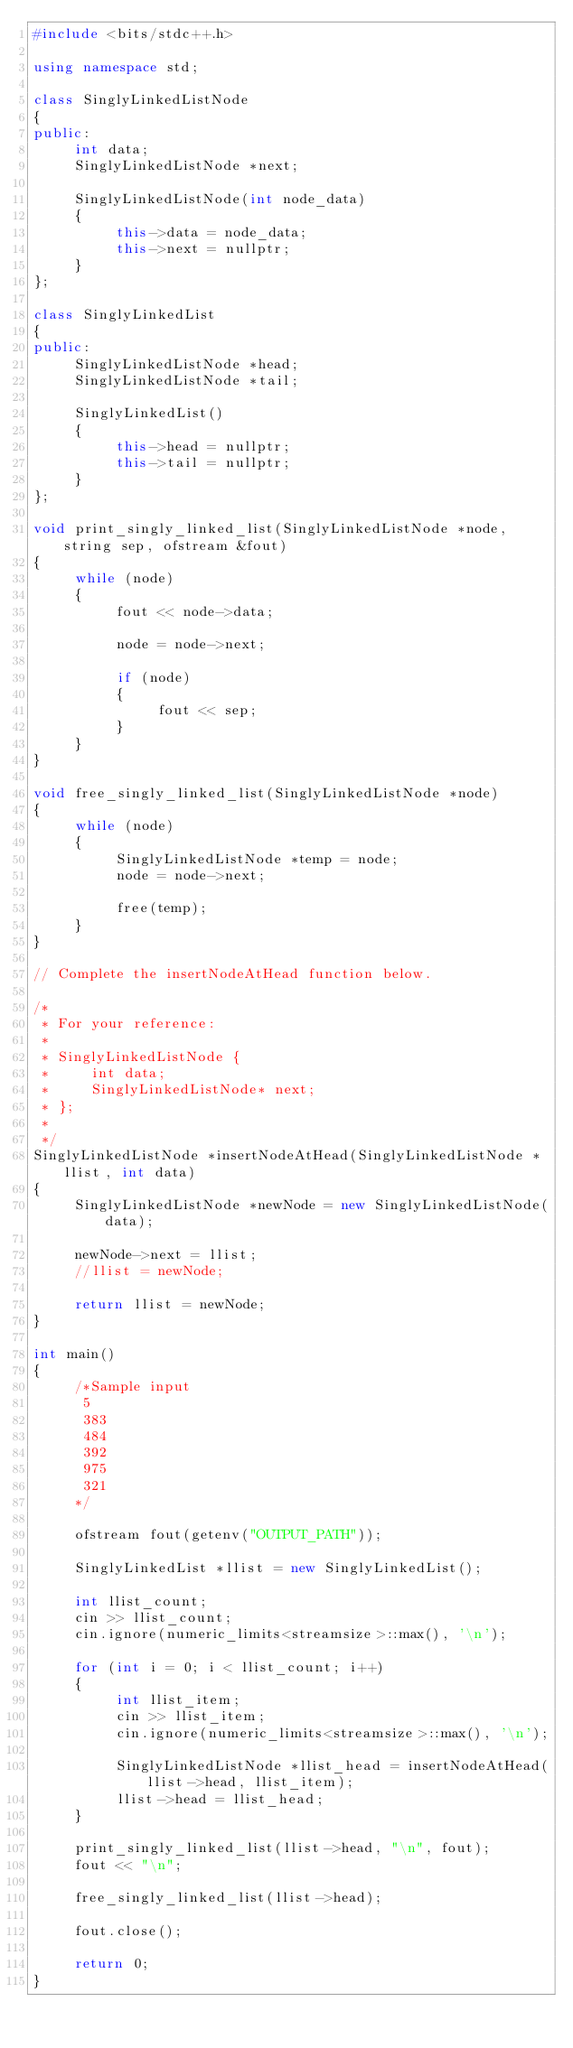Convert code to text. <code><loc_0><loc_0><loc_500><loc_500><_C++_>#include <bits/stdc++.h>

using namespace std;

class SinglyLinkedListNode
{
public:
     int data;
     SinglyLinkedListNode *next;

     SinglyLinkedListNode(int node_data)
     {
          this->data = node_data;
          this->next = nullptr;
     }
};

class SinglyLinkedList
{
public:
     SinglyLinkedListNode *head;
     SinglyLinkedListNode *tail;

     SinglyLinkedList()
     {
          this->head = nullptr;
          this->tail = nullptr;
     }
};

void print_singly_linked_list(SinglyLinkedListNode *node, string sep, ofstream &fout)
{
     while (node)
     {
          fout << node->data;

          node = node->next;

          if (node)
          {
               fout << sep;
          }
     }
}

void free_singly_linked_list(SinglyLinkedListNode *node)
{
     while (node)
     {
          SinglyLinkedListNode *temp = node;
          node = node->next;

          free(temp);
     }
}

// Complete the insertNodeAtHead function below.

/*
 * For your reference:
 *
 * SinglyLinkedListNode {
 *     int data;
 *     SinglyLinkedListNode* next;
 * };
 *
 */
SinglyLinkedListNode *insertNodeAtHead(SinglyLinkedListNode *llist, int data)
{
     SinglyLinkedListNode *newNode = new SinglyLinkedListNode(data);

     newNode->next = llist;
     //llist = newNode;

     return llist = newNode;
}

int main()
{
     /*Sample input
      5
      383
      484
      392
      975
      321
     */

     ofstream fout(getenv("OUTPUT_PATH"));

     SinglyLinkedList *llist = new SinglyLinkedList();

     int llist_count;
     cin >> llist_count;
     cin.ignore(numeric_limits<streamsize>::max(), '\n');

     for (int i = 0; i < llist_count; i++)
     {
          int llist_item;
          cin >> llist_item;
          cin.ignore(numeric_limits<streamsize>::max(), '\n');

          SinglyLinkedListNode *llist_head = insertNodeAtHead(llist->head, llist_item);
          llist->head = llist_head;
     }

     print_singly_linked_list(llist->head, "\n", fout);
     fout << "\n";

     free_singly_linked_list(llist->head);

     fout.close();

     return 0;
}
</code> 